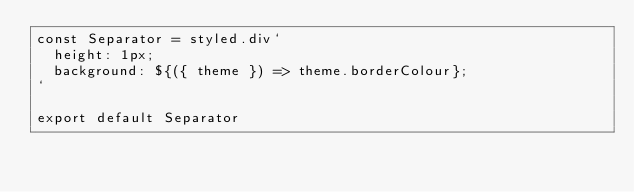<code> <loc_0><loc_0><loc_500><loc_500><_TypeScript_>const Separator = styled.div`
  height: 1px;
  background: ${({ theme }) => theme.borderColour};
`

export default Separator</code> 